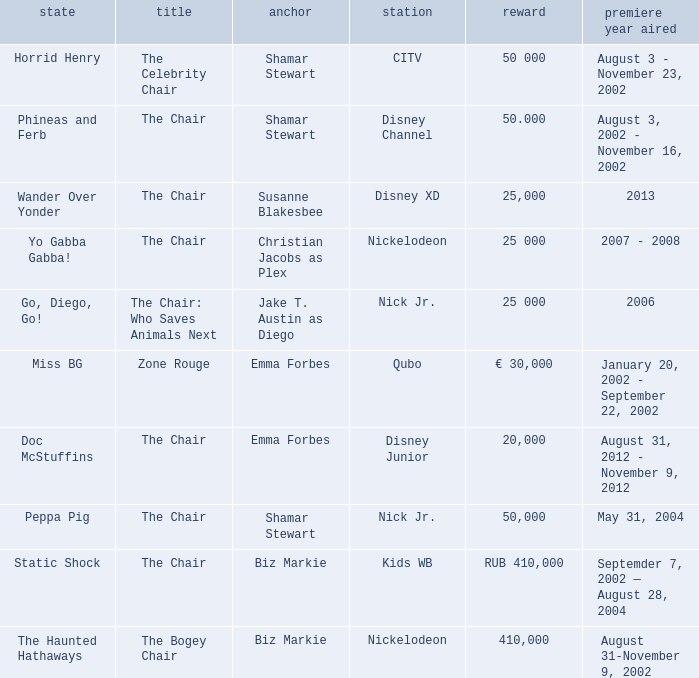What was the host of Horrid Henry? Shamar Stewart. 